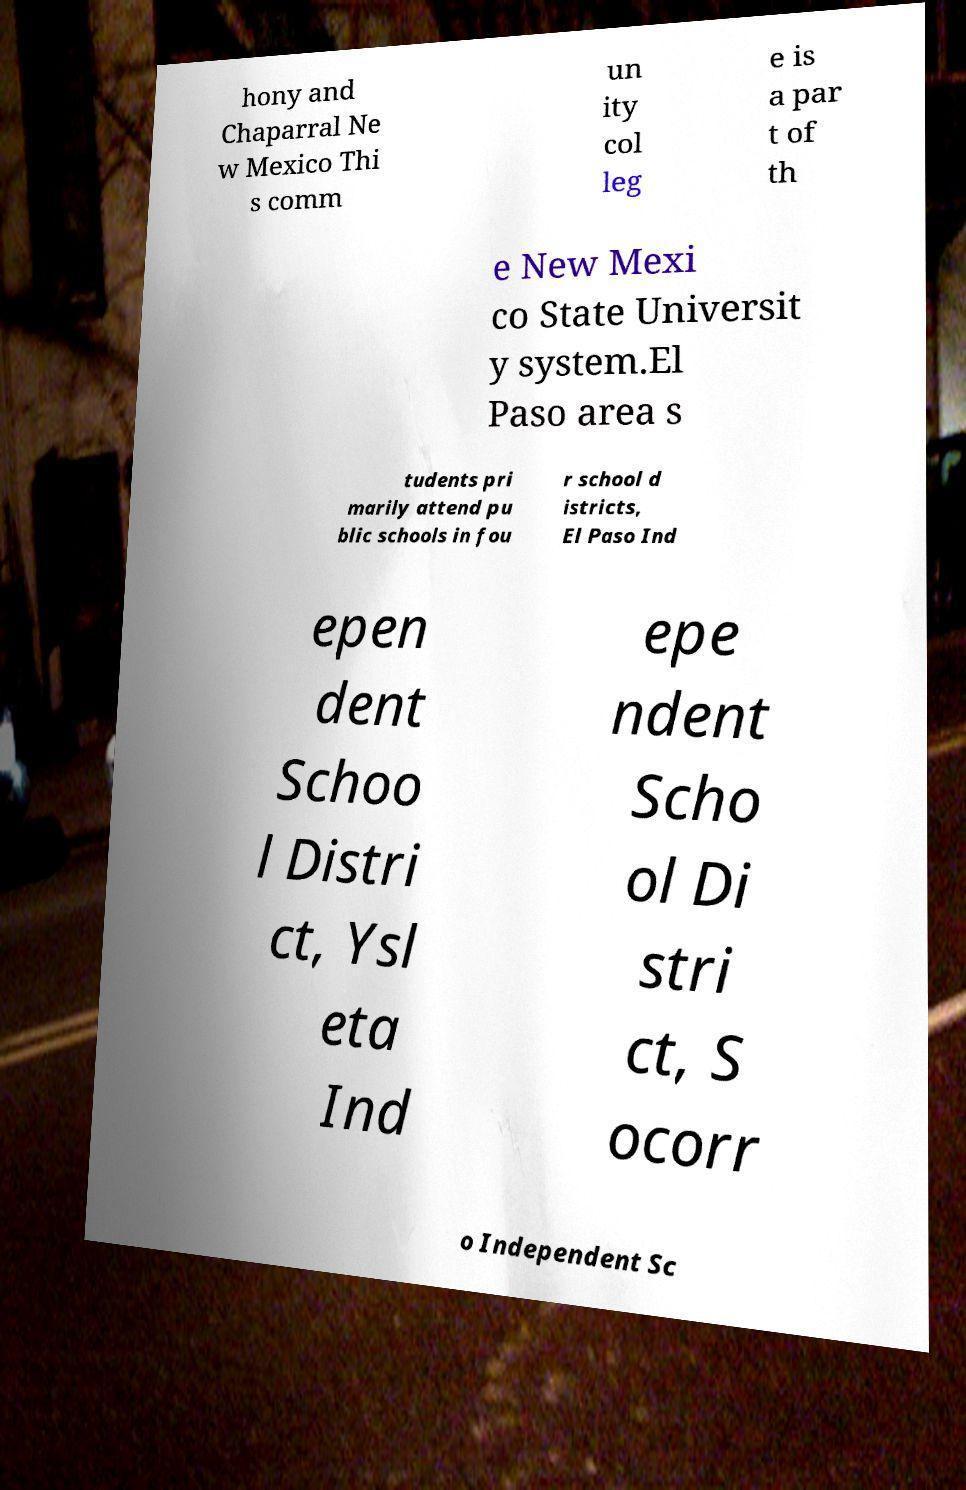Could you assist in decoding the text presented in this image and type it out clearly? hony and Chaparral Ne w Mexico Thi s comm un ity col leg e is a par t of th e New Mexi co State Universit y system.El Paso area s tudents pri marily attend pu blic schools in fou r school d istricts, El Paso Ind epen dent Schoo l Distri ct, Ysl eta Ind epe ndent Scho ol Di stri ct, S ocorr o Independent Sc 